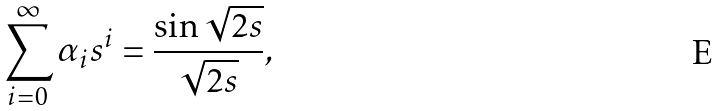<formula> <loc_0><loc_0><loc_500><loc_500>\sum _ { i = 0 } ^ { \infty } \alpha _ { i } s ^ { i } = \frac { \sin \sqrt { 2 s } } { \sqrt { 2 s } } ,</formula> 